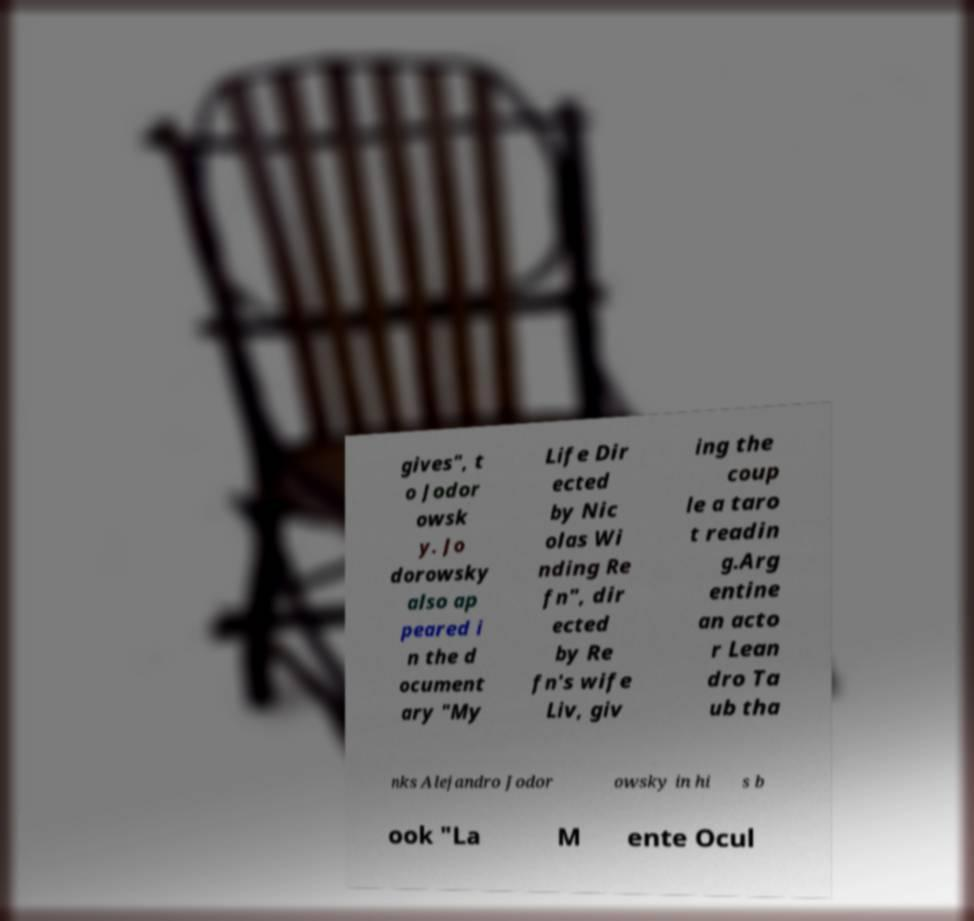Could you extract and type out the text from this image? gives", t o Jodor owsk y. Jo dorowsky also ap peared i n the d ocument ary "My Life Dir ected by Nic olas Wi nding Re fn", dir ected by Re fn's wife Liv, giv ing the coup le a taro t readin g.Arg entine an acto r Lean dro Ta ub tha nks Alejandro Jodor owsky in hi s b ook "La M ente Ocul 